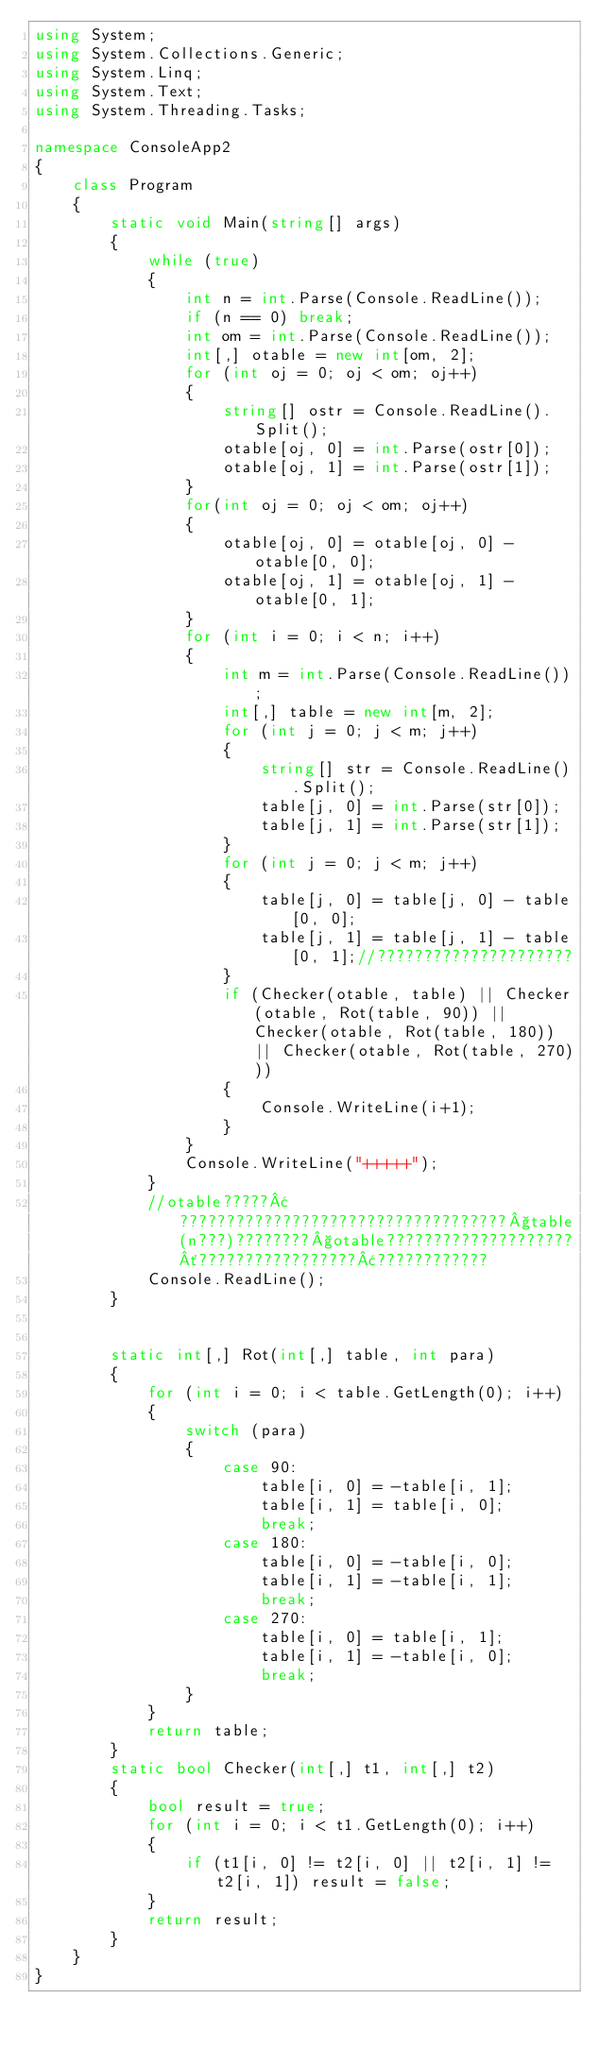<code> <loc_0><loc_0><loc_500><loc_500><_C#_>using System;
using System.Collections.Generic;
using System.Linq;
using System.Text;
using System.Threading.Tasks;

namespace ConsoleApp2
{
    class Program
    {
        static void Main(string[] args)
        {
            while (true)
            {
                int n = int.Parse(Console.ReadLine());
                if (n == 0) break;
                int om = int.Parse(Console.ReadLine());
                int[,] otable = new int[om, 2];
                for (int oj = 0; oj < om; oj++)
                {
                    string[] ostr = Console.ReadLine().Split();
                    otable[oj, 0] = int.Parse(ostr[0]);
                    otable[oj, 1] = int.Parse(ostr[1]);
                }
                for(int oj = 0; oj < om; oj++)
                {
                    otable[oj, 0] = otable[oj, 0] - otable[0, 0];
                    otable[oj, 1] = otable[oj, 1] - otable[0, 1];
                }
                for (int i = 0; i < n; i++)
                {
                    int m = int.Parse(Console.ReadLine());
                    int[,] table = new int[m, 2];
                    for (int j = 0; j < m; j++)
                    {
                        string[] str = Console.ReadLine().Split();
                        table[j, 0] = int.Parse(str[0]);
                        table[j, 1] = int.Parse(str[1]);
                    }
                    for (int j = 0; j < m; j++)
                    {
                        table[j, 0] = table[j, 0] - table[0, 0];
                        table[j, 1] = table[j, 1] - table[0, 1];//?????????????????????
                    }
                    if (Checker(otable, table) || Checker(otable, Rot(table, 90)) || Checker(otable, Rot(table, 180)) || Checker(otable, Rot(table, 270)))
                    {
                        Console.WriteLine(i+1);
                    }
                }
                Console.WriteLine("+++++");
            }
            //otable?????¢???????????????????????????????????§table(n???)????????§otable????????????????????´?????????????????¢????????????
            Console.ReadLine();
        }


        static int[,] Rot(int[,] table, int para)
        {
            for (int i = 0; i < table.GetLength(0); i++)
            {
                switch (para)
                {
                    case 90:
                        table[i, 0] = -table[i, 1];
                        table[i, 1] = table[i, 0];
                        break;
                    case 180:
                        table[i, 0] = -table[i, 0];
                        table[i, 1] = -table[i, 1];
                        break;
                    case 270:
                        table[i, 0] = table[i, 1];
                        table[i, 1] = -table[i, 0];
                        break;
                }
            }
            return table;
        }
        static bool Checker(int[,] t1, int[,] t2)
        {
            bool result = true;
            for (int i = 0; i < t1.GetLength(0); i++)
            {
                if (t1[i, 0] != t2[i, 0] || t2[i, 1] != t2[i, 1]) result = false;
            }
            return result;
        }
    }
}</code> 